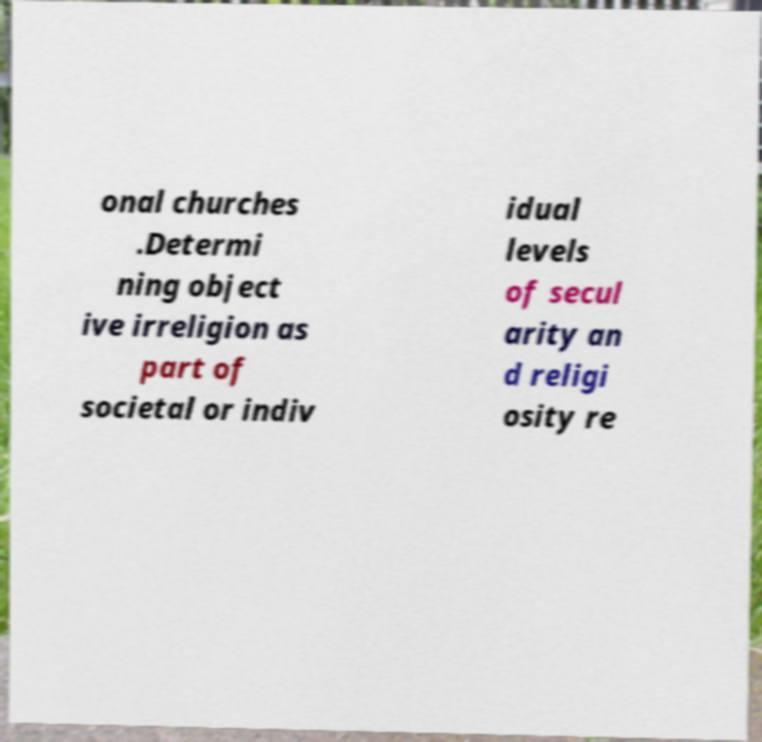For documentation purposes, I need the text within this image transcribed. Could you provide that? onal churches .Determi ning object ive irreligion as part of societal or indiv idual levels of secul arity an d religi osity re 